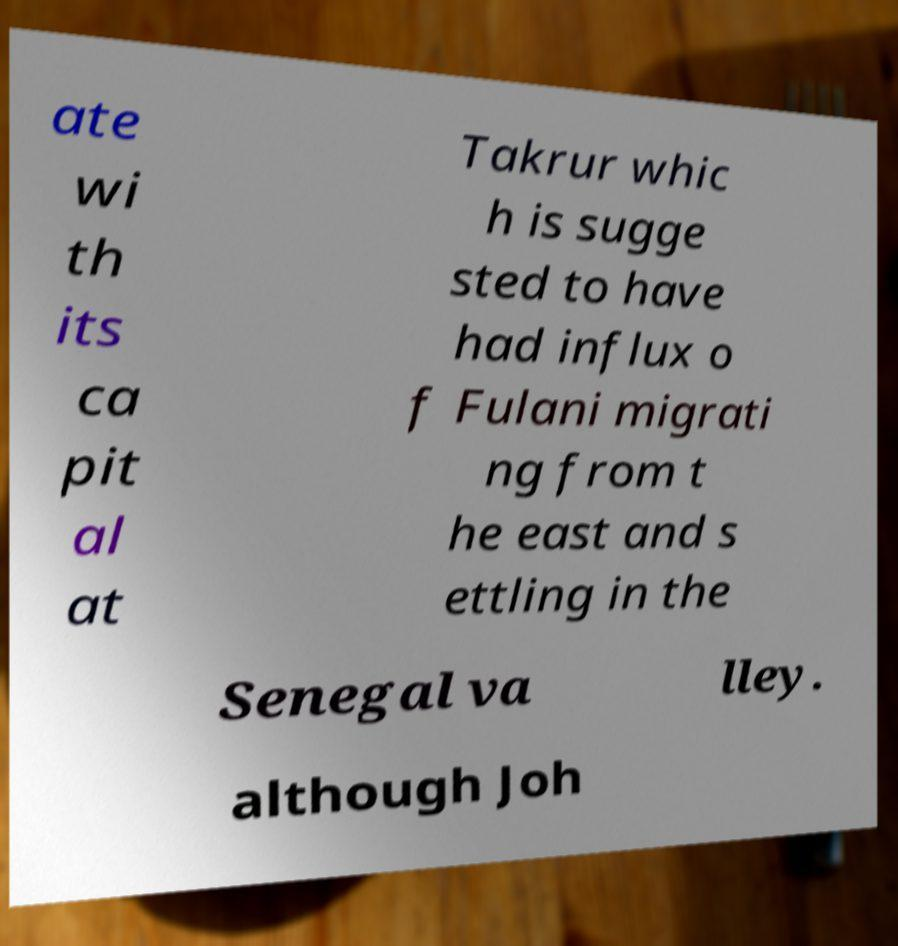Can you read and provide the text displayed in the image?This photo seems to have some interesting text. Can you extract and type it out for me? ate wi th its ca pit al at Takrur whic h is sugge sted to have had influx o f Fulani migrati ng from t he east and s ettling in the Senegal va lley. although Joh 